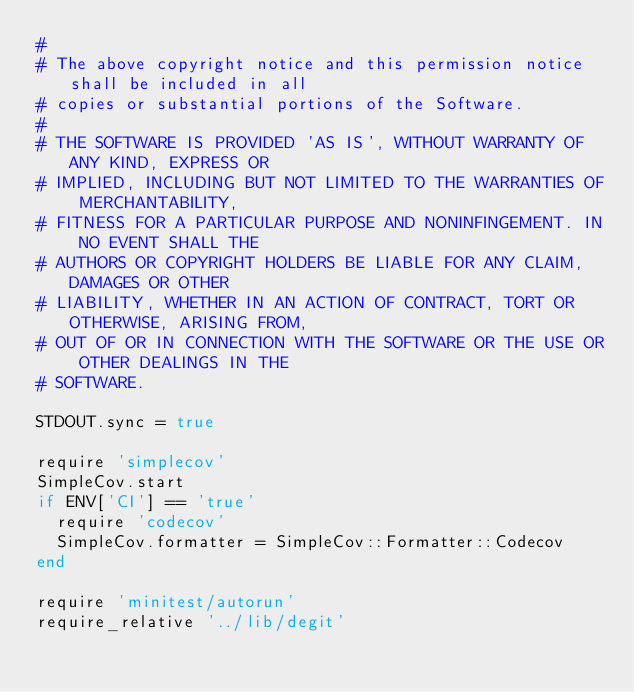Convert code to text. <code><loc_0><loc_0><loc_500><loc_500><_Ruby_>#
# The above copyright notice and this permission notice shall be included in all
# copies or substantial portions of the Software.
#
# THE SOFTWARE IS PROVIDED 'AS IS', WITHOUT WARRANTY OF ANY KIND, EXPRESS OR
# IMPLIED, INCLUDING BUT NOT LIMITED TO THE WARRANTIES OF MERCHANTABILITY,
# FITNESS FOR A PARTICULAR PURPOSE AND NONINFINGEMENT. IN NO EVENT SHALL THE
# AUTHORS OR COPYRIGHT HOLDERS BE LIABLE FOR ANY CLAIM, DAMAGES OR OTHER
# LIABILITY, WHETHER IN AN ACTION OF CONTRACT, TORT OR OTHERWISE, ARISING FROM,
# OUT OF OR IN CONNECTION WITH THE SOFTWARE OR THE USE OR OTHER DEALINGS IN THE
# SOFTWARE.

STDOUT.sync = true

require 'simplecov'
SimpleCov.start
if ENV['CI'] == 'true'
  require 'codecov'
  SimpleCov.formatter = SimpleCov::Formatter::Codecov
end

require 'minitest/autorun'
require_relative '../lib/degit'
</code> 